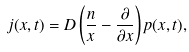Convert formula to latex. <formula><loc_0><loc_0><loc_500><loc_500>j ( x , t ) = D \left ( \frac { n } { x } - \frac { \partial } { \partial x } \right ) p ( x , t ) ,</formula> 